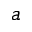<formula> <loc_0><loc_0><loc_500><loc_500>^ { a }</formula> 